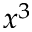Convert formula to latex. <formula><loc_0><loc_0><loc_500><loc_500>x ^ { 3 }</formula> 